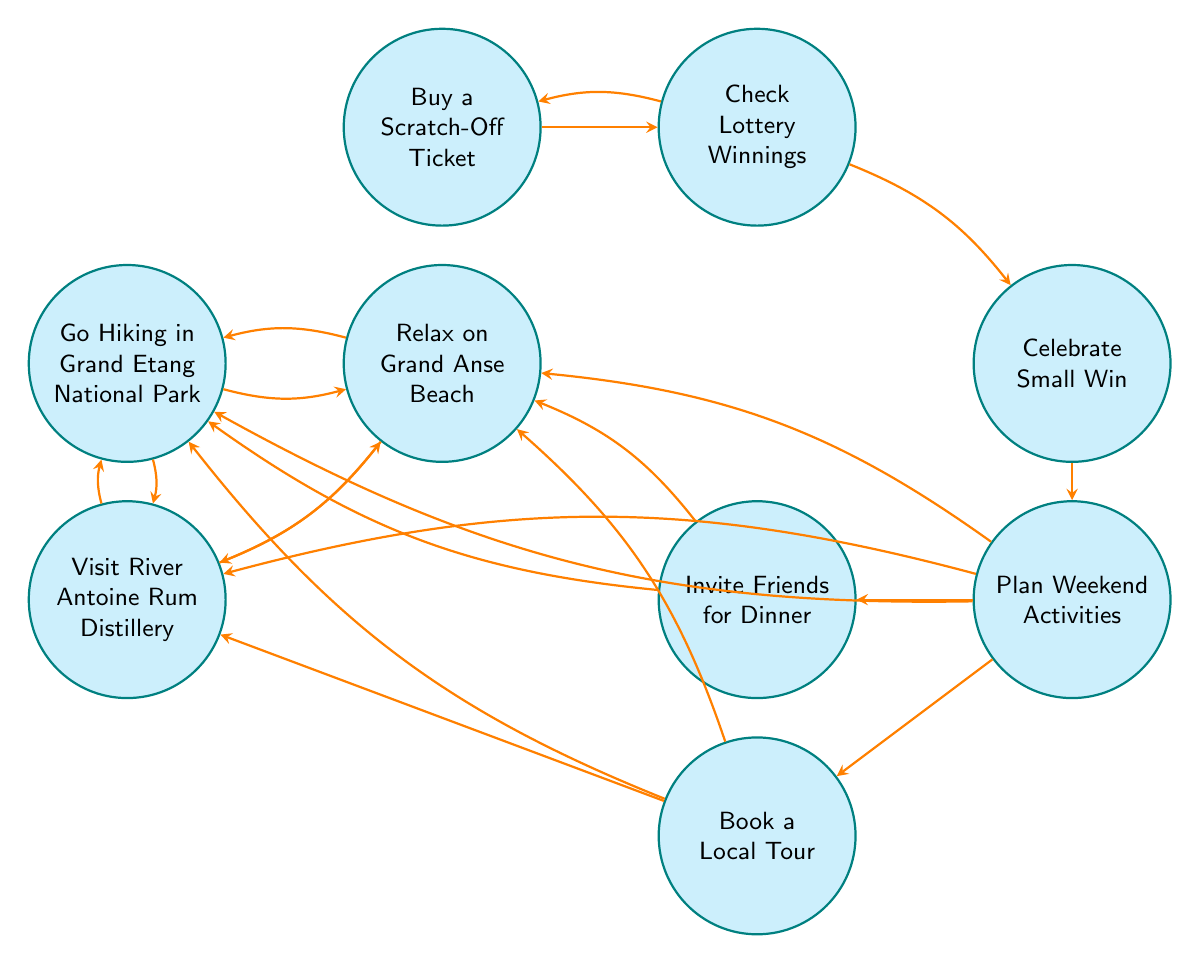What is the first state in the diagram? The first state in the diagram is "Buy a Scratch-Off Ticket," which is the starting point of the finite state machine. This can be identified as the topmost node in the sequence of activities.
Answer: Buy a Scratch-Off Ticket How many states are in the diagram? The diagram contains a total of nine states, which can be counted by reviewing all unique nodes present in it.
Answer: 9 What state follows "Check Lottery Winnings"? The state that immediately follows "Check Lottery Winnings" is "Celebrate Small Win," as there is a direct transition indicated by the arrow from "Check Lottery Winnings" to "Celebrate Small Win."
Answer: Celebrate Small Win Which state has the most outgoing transitions? The state "Plan Weekend Activities" has the most outgoing transitions; it connects to five different activities, as indicated by the multiple arrows leading from this node.
Answer: Plan Weekend Activities Can you travel from "Relax on Grand Anse Beach" to "Visit River Antoine Rum Distillery"? Yes, it is possible to travel from "Relax on Grand Anse Beach" to "Visit River Antoine Rum Distillery," as there is a direct transition indicated by an arrow connecting these two states.
Answer: Yes What two states can you go to from "Book a Local Tour"? From "Book a Local Tour," you can go to "Relax on Grand Anse Beach" and "Go Hiking in Grand Etang National Park." These are both indicated by direct arrows stemming from the "Book a Local Tour" state.
Answer: Relax on Grand Anse Beach, Go Hiking in Grand Etang National Park How do you return to the "Buy a Scratch-Off Ticket" state from "Check Lottery Winnings"? You can return to "Buy a Scratch-Off Ticket" from "Check Lottery Winnings" by following the transition arrow that bends to the left, indicating a loop back to the starting state after checking the winnings.
Answer: By moving clockwise along the path What activities can you plan after celebrating a small win? After celebrating a small win, you can plan five different activities, which are indicated by transitions from the "Celebrate Small Win" state to states like "Book a Local Tour," "Invite Friends for Dinner," "Relax on Grand Anse Beach," "Go Hiking in Grand Etang National Park," and "Visit River Antoine Rum Distillery."
Answer: Book a Local Tour, Invite Friends for Dinner, Relax on Grand Anse Beach, Go Hiking in Grand Etang National Park, Visit River Antoine Rum Distillery What is a dead-end state in this diagram? There are no dead-end states in this diagram, as every state can transition to at least one other state. This indicates a continuous decision-making process without any terminal nodes.
Answer: None 